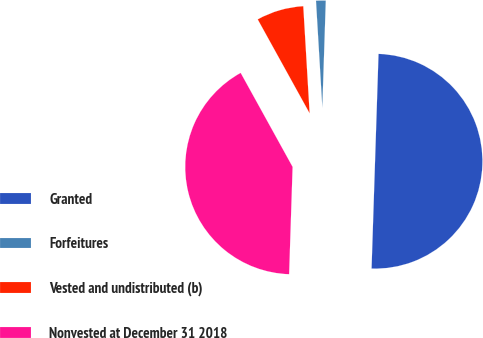Convert chart to OTSL. <chart><loc_0><loc_0><loc_500><loc_500><pie_chart><fcel>Granted<fcel>Forfeitures<fcel>Vested and undistributed (b)<fcel>Nonvested at December 31 2018<nl><fcel>50.0%<fcel>1.46%<fcel>7.09%<fcel>41.45%<nl></chart> 